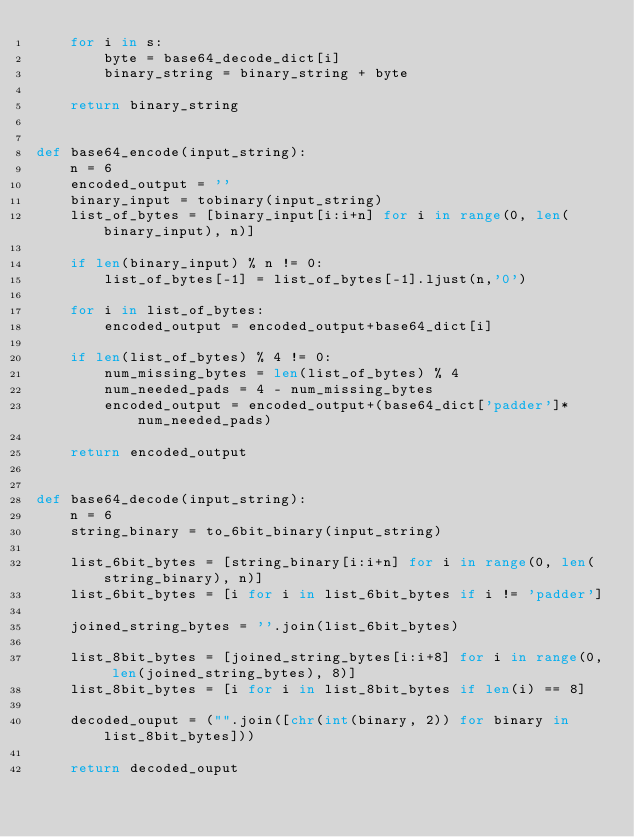<code> <loc_0><loc_0><loc_500><loc_500><_Python_>	for i in s:
		byte = base64_decode_dict[i]
		binary_string = binary_string + byte

	return binary_string


def base64_encode(input_string):
	n = 6
	encoded_output = ''
	binary_input = tobinary(input_string)
	list_of_bytes = [binary_input[i:i+n] for i in range(0, len(binary_input), n)]

	if len(binary_input) % n != 0:
		list_of_bytes[-1] = list_of_bytes[-1].ljust(n,'0')

	for i in list_of_bytes:
		encoded_output = encoded_output+base64_dict[i]

	if len(list_of_bytes) % 4 != 0:
		num_missing_bytes = len(list_of_bytes) % 4
		num_needed_pads = 4 - num_missing_bytes
		encoded_output = encoded_output+(base64_dict['padder']*num_needed_pads)

	return encoded_output


def base64_decode(input_string):
	n = 6
	string_binary = to_6bit_binary(input_string)

	list_6bit_bytes = [string_binary[i:i+n] for i in range(0, len(string_binary), n)]
	list_6bit_bytes = [i for i in list_6bit_bytes if i != 'padder']

	joined_string_bytes = ''.join(list_6bit_bytes)

	list_8bit_bytes = [joined_string_bytes[i:i+8] for i in range(0, len(joined_string_bytes), 8)]
	list_8bit_bytes = [i for i in list_8bit_bytes if len(i) == 8]

	decoded_ouput = ("".join([chr(int(binary, 2)) for binary in list_8bit_bytes]))
	
	return decoded_ouput</code> 